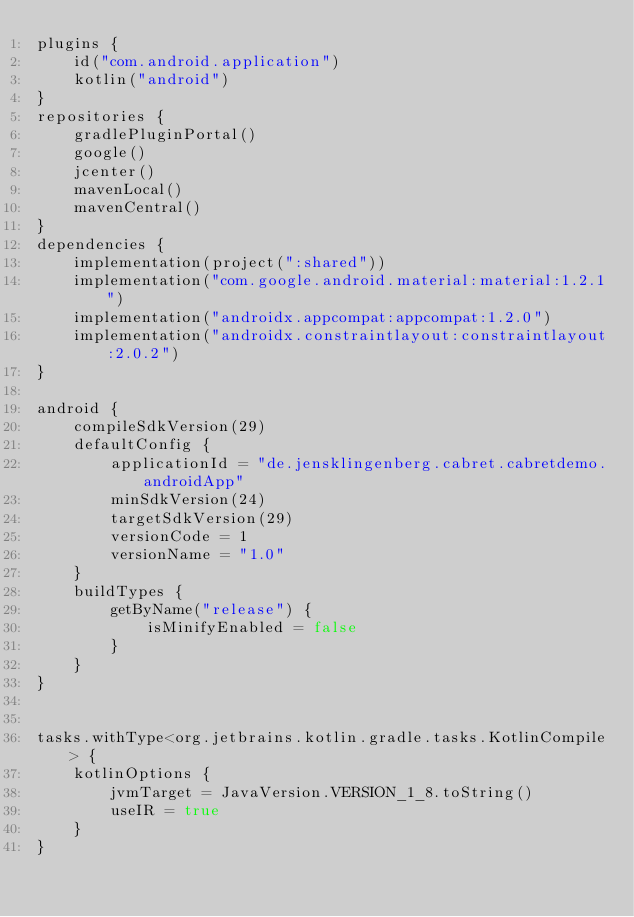<code> <loc_0><loc_0><loc_500><loc_500><_Kotlin_>plugins {
    id("com.android.application")
    kotlin("android")
}
repositories {
    gradlePluginPortal()
    google()
    jcenter()
    mavenLocal()
    mavenCentral()
}
dependencies {
    implementation(project(":shared"))
    implementation("com.google.android.material:material:1.2.1")
    implementation("androidx.appcompat:appcompat:1.2.0")
    implementation("androidx.constraintlayout:constraintlayout:2.0.2")
}

android {
    compileSdkVersion(29)
    defaultConfig {
        applicationId = "de.jensklingenberg.cabret.cabretdemo.androidApp"
        minSdkVersion(24)
        targetSdkVersion(29)
        versionCode = 1
        versionName = "1.0"
    }
    buildTypes {
        getByName("release") {
            isMinifyEnabled = false
        }
    }
}


tasks.withType<org.jetbrains.kotlin.gradle.tasks.KotlinCompile> {
    kotlinOptions {
        jvmTarget = JavaVersion.VERSION_1_8.toString()
        useIR = true
    }
}</code> 